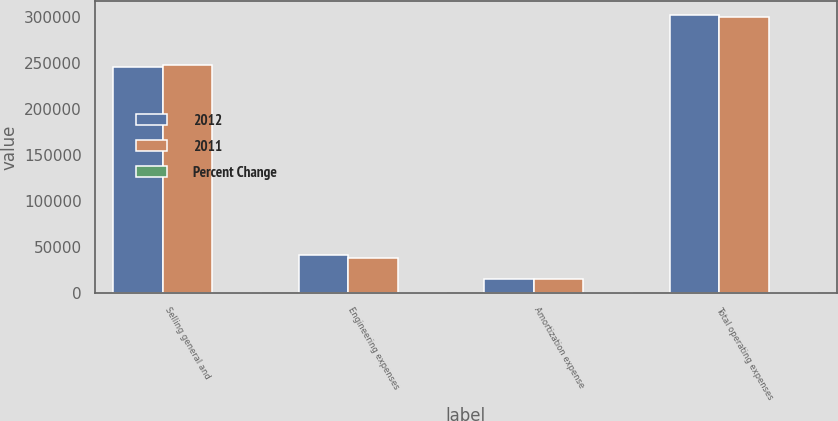Convert chart. <chart><loc_0><loc_0><loc_500><loc_500><stacked_bar_chart><ecel><fcel>Selling general and<fcel>Engineering expenses<fcel>Amortization expense<fcel>Total operating expenses<nl><fcel>2012<fcel>245709<fcel>41307<fcel>15272<fcel>302288<nl><fcel>2011<fcel>247534<fcel>37193<fcel>14996<fcel>299723<nl><fcel>Percent Change<fcel>0.7<fcel>11.1<fcel>1.8<fcel>0.9<nl></chart> 